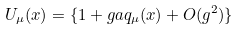<formula> <loc_0><loc_0><loc_500><loc_500>U _ { \mu } ( x ) = \{ 1 + g a q _ { \mu } ( x ) + O ( g ^ { 2 } ) \}</formula> 